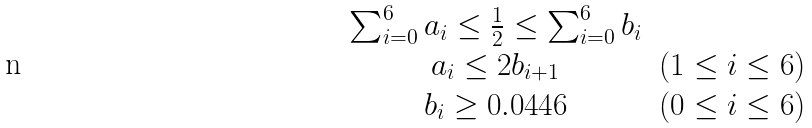<formula> <loc_0><loc_0><loc_500><loc_500>\begin{array} { c c } \sum _ { i = 0 } ^ { 6 } a _ { i } \leq \frac { 1 } { 2 } \leq \sum _ { i = 0 } ^ { 6 } b _ { i } & \\ a _ { i } \leq 2 b _ { i + 1 } & ( 1 \leq i \leq 6 ) \\ b _ { i } \geq 0 . 0 4 4 6 & ( 0 \leq i \leq 6 ) \\ \end{array}</formula> 